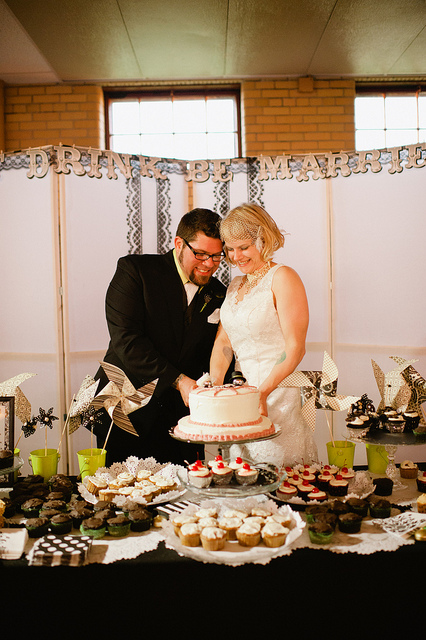What occasion does this image likely depict? This image likely depicts a wedding reception, evidenced by the 'DRINK GET MARRIED' banner in the background, the formal attire of the individuals who appear to be a bride and groom, and the wedding cake they are cutting. What decor theme can be inferred from this image? The decor theme seems to incorporate a whimsical and elegant style, with a monochromatic palette predominantly featuring black and white elements. The presence of paper pinwheels and the mix of desserts on the table suggest a playful yet sophisticated vibe. 